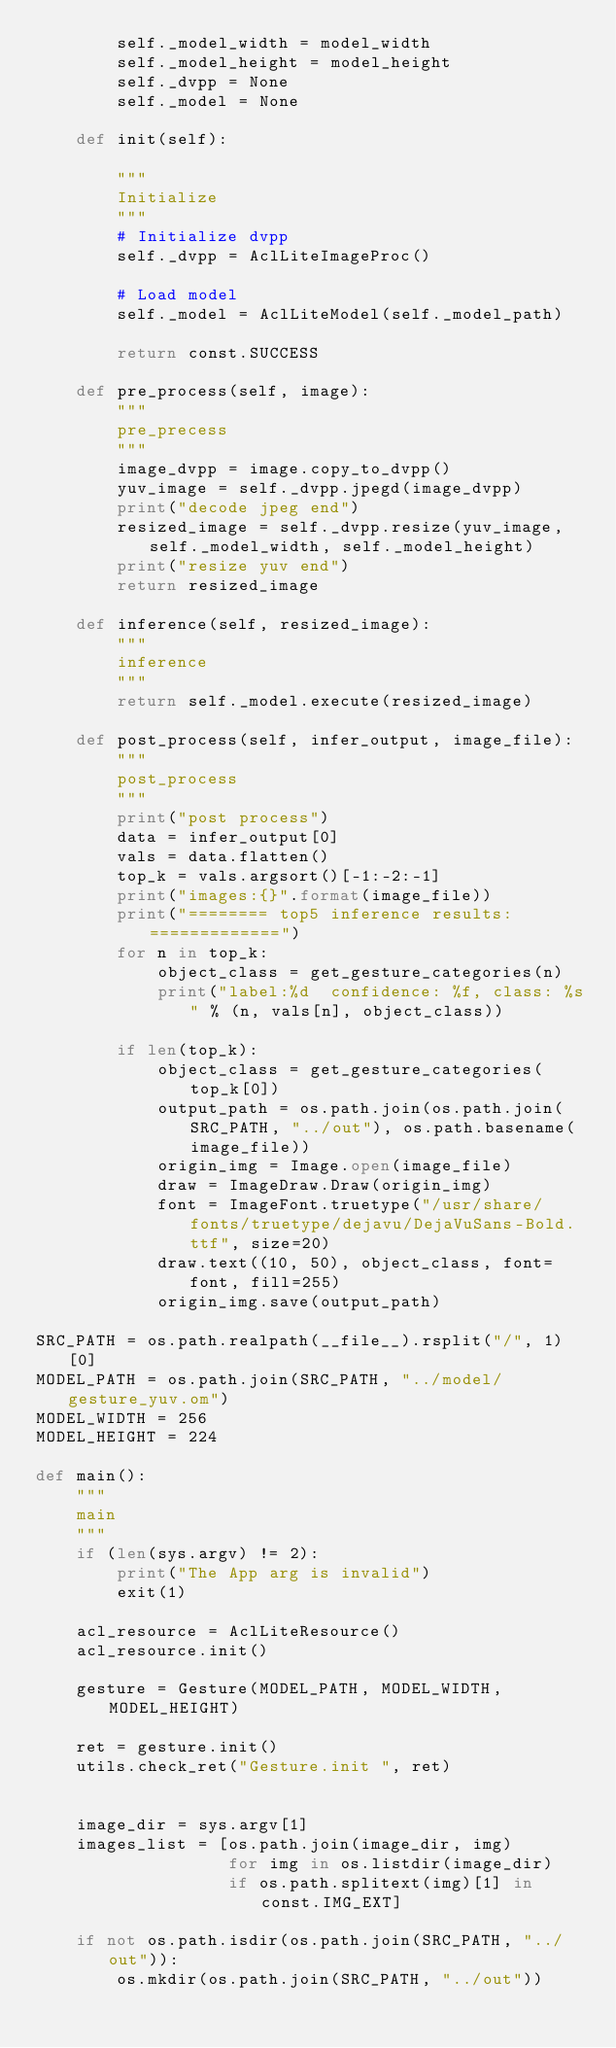Convert code to text. <code><loc_0><loc_0><loc_500><loc_500><_Python_>        self._model_width = model_width
        self._model_height = model_height
        self._dvpp = None
        self._model = None
    
    def init(self):
     
        """
        Initialize
        """
        # Initialize dvpp
        self._dvpp = AclLiteImageProc()

        # Load model
        self._model = AclLiteModel(self._model_path)

        return const.SUCCESS

    def pre_process(self, image):
        """
        pre_precess
        """
        image_dvpp = image.copy_to_dvpp()
        yuv_image = self._dvpp.jpegd(image_dvpp)
        print("decode jpeg end")
        resized_image = self._dvpp.resize(yuv_image, self._model_width, self._model_height)
        print("resize yuv end")
        return resized_image

    def inference(self, resized_image):
        """
	    inference
        """
        return self._model.execute(resized_image)

    def post_process(self, infer_output, image_file):
        """
	    post_process
        """
        print("post process")
        data = infer_output[0]
        vals = data.flatten()
        top_k = vals.argsort()[-1:-2:-1]
        print("images:{}".format(image_file))
        print("======== top5 inference results: =============")
        for n in top_k:
            object_class = get_gesture_categories(n)
            print("label:%d  confidence: %f, class: %s" % (n, vals[n], object_class))
       
        if len(top_k):
            object_class = get_gesture_categories(top_k[0])
            output_path = os.path.join(os.path.join(SRC_PATH, "../out"), os.path.basename(image_file))
            origin_img = Image.open(image_file)
            draw = ImageDraw.Draw(origin_img)
            font = ImageFont.truetype("/usr/share/fonts/truetype/dejavu/DejaVuSans-Bold.ttf", size=20)
            draw.text((10, 50), object_class, font=font, fill=255)
            origin_img.save(output_path)

SRC_PATH = os.path.realpath(__file__).rsplit("/", 1)[0]
MODEL_PATH = os.path.join(SRC_PATH, "../model/gesture_yuv.om")
MODEL_WIDTH = 256
MODEL_HEIGHT = 224

def main():
    """
    main
    """
    if (len(sys.argv) != 2):
        print("The App arg is invalid")
        exit(1)
    
    acl_resource = AclLiteResource()
    acl_resource.init()
    
    gesture = Gesture(MODEL_PATH, MODEL_WIDTH, MODEL_HEIGHT)
    
    ret = gesture.init()
    utils.check_ret("Gesture.init ", ret)
    
   
    image_dir = sys.argv[1]
    images_list = [os.path.join(image_dir, img)
                   for img in os.listdir(image_dir)
                   if os.path.splitext(img)[1] in const.IMG_EXT]
    
    if not os.path.isdir(os.path.join(SRC_PATH, "../out")):
        os.mkdir(os.path.join(SRC_PATH, "../out"))
</code> 